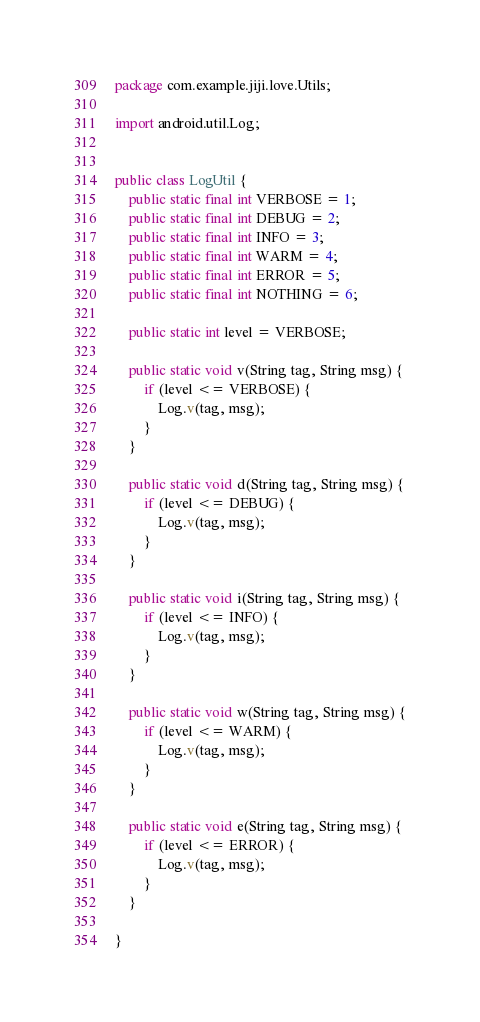<code> <loc_0><loc_0><loc_500><loc_500><_Java_>package com.example.jiji.love.Utils;

import android.util.Log;


public class LogUtil {
    public static final int VERBOSE = 1;
    public static final int DEBUG = 2;
    public static final int INFO = 3;
    public static final int WARM = 4;
    public static final int ERROR = 5;
    public static final int NOTHING = 6;

    public static int level = VERBOSE;

    public static void v(String tag, String msg) {
        if (level <= VERBOSE) {
            Log.v(tag, msg);
        }
    }

    public static void d(String tag, String msg) {
        if (level <= DEBUG) {
            Log.v(tag, msg);
        }
    }

    public static void i(String tag, String msg) {
        if (level <= INFO) {
            Log.v(tag, msg);
        }
    }

    public static void w(String tag, String msg) {
        if (level <= WARM) {
            Log.v(tag, msg);
        }
    }

    public static void e(String tag, String msg) {
        if (level <= ERROR) {
            Log.v(tag, msg);
        }
    }

}
</code> 